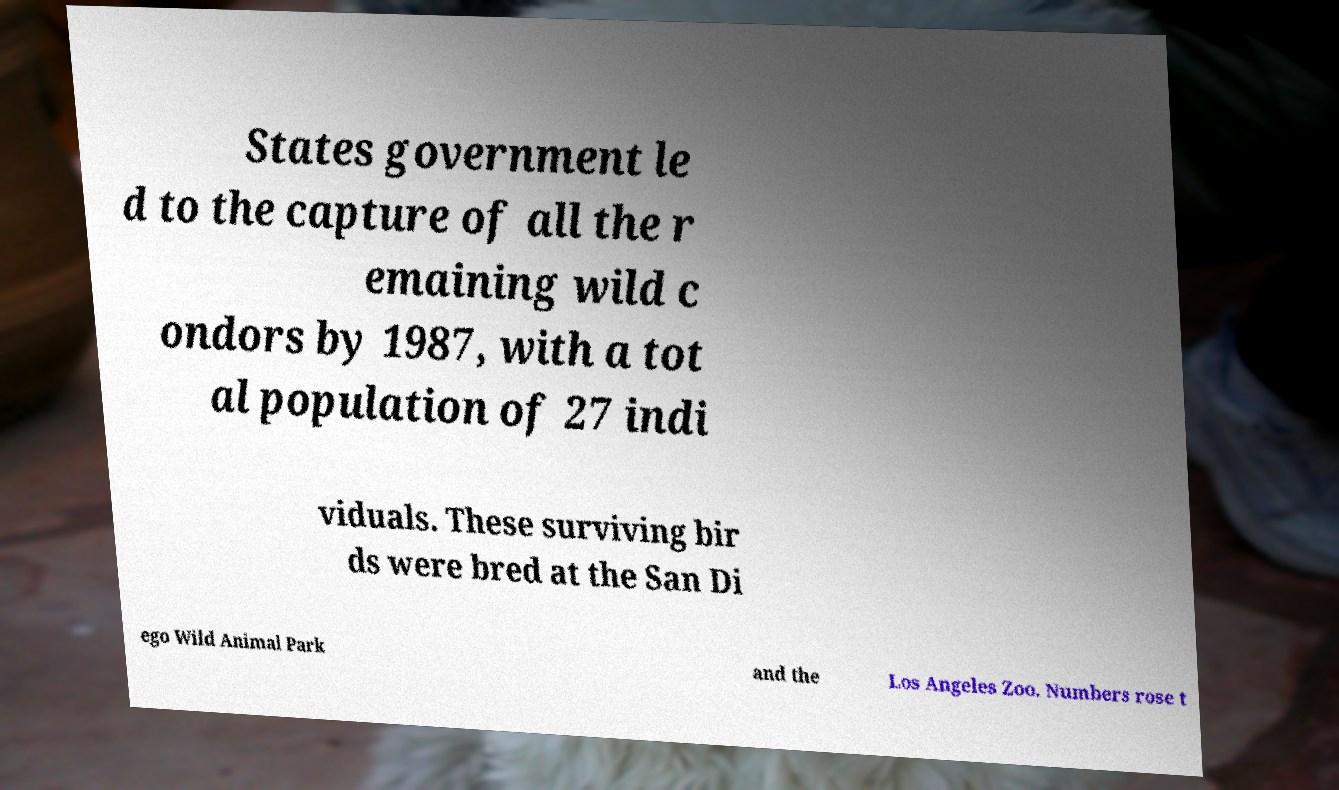I need the written content from this picture converted into text. Can you do that? States government le d to the capture of all the r emaining wild c ondors by 1987, with a tot al population of 27 indi viduals. These surviving bir ds were bred at the San Di ego Wild Animal Park and the Los Angeles Zoo. Numbers rose t 